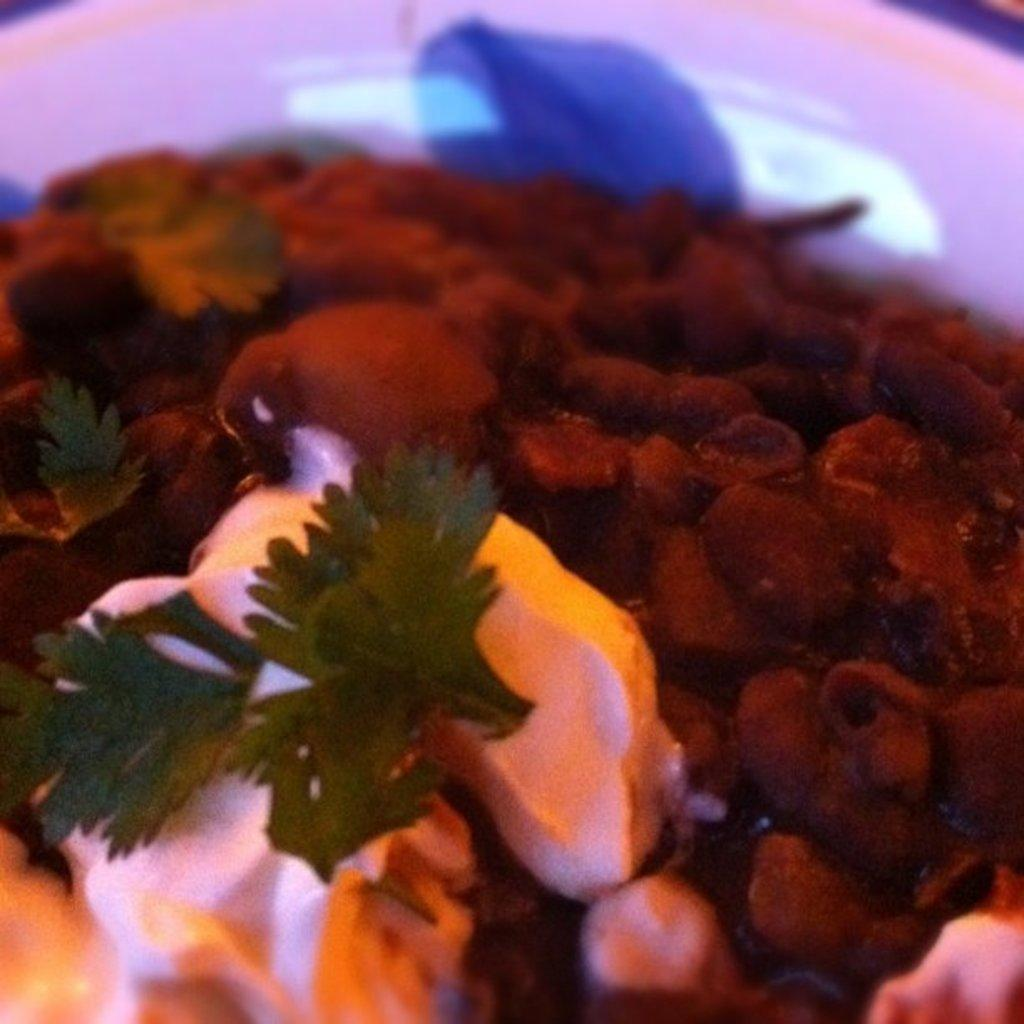What type of food can be seen in the image? The image contains food that appears to be meat. What herb is accompanying the food? Coriander is present with the food. How is the food arranged in the image? The food is placed on a plate. What color is the plate? The plate is white in color. How many pigs are running in the image? There are no pigs present in the image, and they are not running. What type of base is supporting the plate in the image? The image does not show the base supporting the plate, so it cannot be determined. 